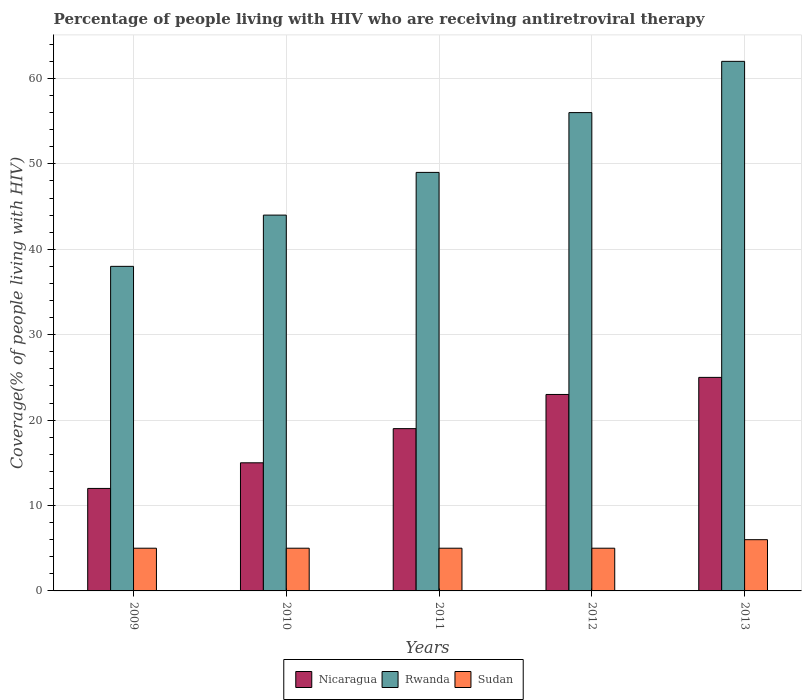How many groups of bars are there?
Your answer should be compact. 5. Are the number of bars on each tick of the X-axis equal?
Ensure brevity in your answer.  Yes. How many bars are there on the 1st tick from the left?
Offer a very short reply. 3. How many bars are there on the 1st tick from the right?
Your answer should be very brief. 3. What is the percentage of the HIV infected people who are receiving antiretroviral therapy in Nicaragua in 2011?
Your answer should be very brief. 19. Across all years, what is the maximum percentage of the HIV infected people who are receiving antiretroviral therapy in Nicaragua?
Give a very brief answer. 25. Across all years, what is the minimum percentage of the HIV infected people who are receiving antiretroviral therapy in Nicaragua?
Ensure brevity in your answer.  12. In which year was the percentage of the HIV infected people who are receiving antiretroviral therapy in Rwanda minimum?
Offer a very short reply. 2009. What is the total percentage of the HIV infected people who are receiving antiretroviral therapy in Rwanda in the graph?
Keep it short and to the point. 249. What is the difference between the percentage of the HIV infected people who are receiving antiretroviral therapy in Nicaragua in 2009 and that in 2012?
Offer a terse response. -11. What is the difference between the percentage of the HIV infected people who are receiving antiretroviral therapy in Rwanda in 2009 and the percentage of the HIV infected people who are receiving antiretroviral therapy in Sudan in 2013?
Make the answer very short. 32. What is the average percentage of the HIV infected people who are receiving antiretroviral therapy in Sudan per year?
Your response must be concise. 5.2. In the year 2010, what is the difference between the percentage of the HIV infected people who are receiving antiretroviral therapy in Sudan and percentage of the HIV infected people who are receiving antiretroviral therapy in Nicaragua?
Offer a terse response. -10. In how many years, is the percentage of the HIV infected people who are receiving antiretroviral therapy in Sudan greater than 30 %?
Make the answer very short. 0. What is the ratio of the percentage of the HIV infected people who are receiving antiretroviral therapy in Rwanda in 2011 to that in 2013?
Make the answer very short. 0.79. What is the difference between the highest and the second highest percentage of the HIV infected people who are receiving antiretroviral therapy in Nicaragua?
Give a very brief answer. 2. What is the difference between the highest and the lowest percentage of the HIV infected people who are receiving antiretroviral therapy in Nicaragua?
Your answer should be very brief. 13. What does the 1st bar from the left in 2011 represents?
Give a very brief answer. Nicaragua. What does the 1st bar from the right in 2009 represents?
Your answer should be very brief. Sudan. Is it the case that in every year, the sum of the percentage of the HIV infected people who are receiving antiretroviral therapy in Sudan and percentage of the HIV infected people who are receiving antiretroviral therapy in Rwanda is greater than the percentage of the HIV infected people who are receiving antiretroviral therapy in Nicaragua?
Your answer should be compact. Yes. How many bars are there?
Your response must be concise. 15. Are all the bars in the graph horizontal?
Offer a very short reply. No. How many years are there in the graph?
Keep it short and to the point. 5. What is the difference between two consecutive major ticks on the Y-axis?
Your response must be concise. 10. Does the graph contain grids?
Provide a short and direct response. Yes. How many legend labels are there?
Offer a terse response. 3. How are the legend labels stacked?
Your answer should be very brief. Horizontal. What is the title of the graph?
Offer a very short reply. Percentage of people living with HIV who are receiving antiretroviral therapy. What is the label or title of the Y-axis?
Provide a short and direct response. Coverage(% of people living with HIV). What is the Coverage(% of people living with HIV) of Nicaragua in 2009?
Make the answer very short. 12. What is the Coverage(% of people living with HIV) of Sudan in 2009?
Offer a terse response. 5. What is the Coverage(% of people living with HIV) in Nicaragua in 2010?
Keep it short and to the point. 15. What is the Coverage(% of people living with HIV) of Sudan in 2010?
Make the answer very short. 5. What is the Coverage(% of people living with HIV) in Nicaragua in 2011?
Your answer should be very brief. 19. What is the Coverage(% of people living with HIV) of Nicaragua in 2013?
Give a very brief answer. 25. What is the Coverage(% of people living with HIV) in Sudan in 2013?
Your answer should be compact. 6. Across all years, what is the maximum Coverage(% of people living with HIV) in Rwanda?
Provide a succinct answer. 62. Across all years, what is the maximum Coverage(% of people living with HIV) in Sudan?
Your answer should be very brief. 6. What is the total Coverage(% of people living with HIV) of Nicaragua in the graph?
Keep it short and to the point. 94. What is the total Coverage(% of people living with HIV) in Rwanda in the graph?
Ensure brevity in your answer.  249. What is the difference between the Coverage(% of people living with HIV) in Nicaragua in 2009 and that in 2011?
Give a very brief answer. -7. What is the difference between the Coverage(% of people living with HIV) of Rwanda in 2009 and that in 2011?
Make the answer very short. -11. What is the difference between the Coverage(% of people living with HIV) of Sudan in 2009 and that in 2011?
Keep it short and to the point. 0. What is the difference between the Coverage(% of people living with HIV) of Nicaragua in 2009 and that in 2012?
Give a very brief answer. -11. What is the difference between the Coverage(% of people living with HIV) of Rwanda in 2009 and that in 2013?
Offer a very short reply. -24. What is the difference between the Coverage(% of people living with HIV) in Sudan in 2009 and that in 2013?
Your answer should be compact. -1. What is the difference between the Coverage(% of people living with HIV) in Nicaragua in 2010 and that in 2011?
Ensure brevity in your answer.  -4. What is the difference between the Coverage(% of people living with HIV) of Nicaragua in 2010 and that in 2013?
Give a very brief answer. -10. What is the difference between the Coverage(% of people living with HIV) of Rwanda in 2010 and that in 2013?
Make the answer very short. -18. What is the difference between the Coverage(% of people living with HIV) of Nicaragua in 2011 and that in 2012?
Keep it short and to the point. -4. What is the difference between the Coverage(% of people living with HIV) of Sudan in 2011 and that in 2013?
Your answer should be compact. -1. What is the difference between the Coverage(% of people living with HIV) in Rwanda in 2012 and that in 2013?
Provide a succinct answer. -6. What is the difference between the Coverage(% of people living with HIV) in Nicaragua in 2009 and the Coverage(% of people living with HIV) in Rwanda in 2010?
Provide a short and direct response. -32. What is the difference between the Coverage(% of people living with HIV) of Nicaragua in 2009 and the Coverage(% of people living with HIV) of Rwanda in 2011?
Offer a terse response. -37. What is the difference between the Coverage(% of people living with HIV) of Nicaragua in 2009 and the Coverage(% of people living with HIV) of Sudan in 2011?
Make the answer very short. 7. What is the difference between the Coverage(% of people living with HIV) in Nicaragua in 2009 and the Coverage(% of people living with HIV) in Rwanda in 2012?
Your answer should be compact. -44. What is the difference between the Coverage(% of people living with HIV) in Rwanda in 2009 and the Coverage(% of people living with HIV) in Sudan in 2012?
Make the answer very short. 33. What is the difference between the Coverage(% of people living with HIV) of Nicaragua in 2009 and the Coverage(% of people living with HIV) of Rwanda in 2013?
Keep it short and to the point. -50. What is the difference between the Coverage(% of people living with HIV) in Nicaragua in 2009 and the Coverage(% of people living with HIV) in Sudan in 2013?
Ensure brevity in your answer.  6. What is the difference between the Coverage(% of people living with HIV) of Nicaragua in 2010 and the Coverage(% of people living with HIV) of Rwanda in 2011?
Ensure brevity in your answer.  -34. What is the difference between the Coverage(% of people living with HIV) in Rwanda in 2010 and the Coverage(% of people living with HIV) in Sudan in 2011?
Offer a very short reply. 39. What is the difference between the Coverage(% of people living with HIV) of Nicaragua in 2010 and the Coverage(% of people living with HIV) of Rwanda in 2012?
Offer a very short reply. -41. What is the difference between the Coverage(% of people living with HIV) in Nicaragua in 2010 and the Coverage(% of people living with HIV) in Sudan in 2012?
Your answer should be very brief. 10. What is the difference between the Coverage(% of people living with HIV) of Rwanda in 2010 and the Coverage(% of people living with HIV) of Sudan in 2012?
Provide a succinct answer. 39. What is the difference between the Coverage(% of people living with HIV) in Nicaragua in 2010 and the Coverage(% of people living with HIV) in Rwanda in 2013?
Keep it short and to the point. -47. What is the difference between the Coverage(% of people living with HIV) of Rwanda in 2010 and the Coverage(% of people living with HIV) of Sudan in 2013?
Offer a terse response. 38. What is the difference between the Coverage(% of people living with HIV) of Nicaragua in 2011 and the Coverage(% of people living with HIV) of Rwanda in 2012?
Provide a succinct answer. -37. What is the difference between the Coverage(% of people living with HIV) of Nicaragua in 2011 and the Coverage(% of people living with HIV) of Sudan in 2012?
Your answer should be compact. 14. What is the difference between the Coverage(% of people living with HIV) of Nicaragua in 2011 and the Coverage(% of people living with HIV) of Rwanda in 2013?
Your answer should be very brief. -43. What is the difference between the Coverage(% of people living with HIV) of Nicaragua in 2012 and the Coverage(% of people living with HIV) of Rwanda in 2013?
Give a very brief answer. -39. What is the difference between the Coverage(% of people living with HIV) in Rwanda in 2012 and the Coverage(% of people living with HIV) in Sudan in 2013?
Give a very brief answer. 50. What is the average Coverage(% of people living with HIV) of Rwanda per year?
Keep it short and to the point. 49.8. In the year 2009, what is the difference between the Coverage(% of people living with HIV) in Nicaragua and Coverage(% of people living with HIV) in Sudan?
Provide a short and direct response. 7. In the year 2010, what is the difference between the Coverage(% of people living with HIV) in Nicaragua and Coverage(% of people living with HIV) in Rwanda?
Offer a very short reply. -29. In the year 2012, what is the difference between the Coverage(% of people living with HIV) in Nicaragua and Coverage(% of people living with HIV) in Rwanda?
Your answer should be compact. -33. In the year 2013, what is the difference between the Coverage(% of people living with HIV) of Nicaragua and Coverage(% of people living with HIV) of Rwanda?
Provide a succinct answer. -37. In the year 2013, what is the difference between the Coverage(% of people living with HIV) of Rwanda and Coverage(% of people living with HIV) of Sudan?
Provide a succinct answer. 56. What is the ratio of the Coverage(% of people living with HIV) in Rwanda in 2009 to that in 2010?
Your answer should be compact. 0.86. What is the ratio of the Coverage(% of people living with HIV) in Nicaragua in 2009 to that in 2011?
Make the answer very short. 0.63. What is the ratio of the Coverage(% of people living with HIV) of Rwanda in 2009 to that in 2011?
Keep it short and to the point. 0.78. What is the ratio of the Coverage(% of people living with HIV) in Sudan in 2009 to that in 2011?
Make the answer very short. 1. What is the ratio of the Coverage(% of people living with HIV) of Nicaragua in 2009 to that in 2012?
Keep it short and to the point. 0.52. What is the ratio of the Coverage(% of people living with HIV) in Rwanda in 2009 to that in 2012?
Your response must be concise. 0.68. What is the ratio of the Coverage(% of people living with HIV) of Sudan in 2009 to that in 2012?
Your answer should be compact. 1. What is the ratio of the Coverage(% of people living with HIV) of Nicaragua in 2009 to that in 2013?
Provide a succinct answer. 0.48. What is the ratio of the Coverage(% of people living with HIV) of Rwanda in 2009 to that in 2013?
Ensure brevity in your answer.  0.61. What is the ratio of the Coverage(% of people living with HIV) of Sudan in 2009 to that in 2013?
Provide a short and direct response. 0.83. What is the ratio of the Coverage(% of people living with HIV) of Nicaragua in 2010 to that in 2011?
Your answer should be very brief. 0.79. What is the ratio of the Coverage(% of people living with HIV) in Rwanda in 2010 to that in 2011?
Your response must be concise. 0.9. What is the ratio of the Coverage(% of people living with HIV) in Sudan in 2010 to that in 2011?
Your answer should be compact. 1. What is the ratio of the Coverage(% of people living with HIV) of Nicaragua in 2010 to that in 2012?
Your answer should be compact. 0.65. What is the ratio of the Coverage(% of people living with HIV) of Rwanda in 2010 to that in 2012?
Ensure brevity in your answer.  0.79. What is the ratio of the Coverage(% of people living with HIV) in Nicaragua in 2010 to that in 2013?
Make the answer very short. 0.6. What is the ratio of the Coverage(% of people living with HIV) in Rwanda in 2010 to that in 2013?
Give a very brief answer. 0.71. What is the ratio of the Coverage(% of people living with HIV) of Sudan in 2010 to that in 2013?
Make the answer very short. 0.83. What is the ratio of the Coverage(% of people living with HIV) in Nicaragua in 2011 to that in 2012?
Make the answer very short. 0.83. What is the ratio of the Coverage(% of people living with HIV) in Nicaragua in 2011 to that in 2013?
Keep it short and to the point. 0.76. What is the ratio of the Coverage(% of people living with HIV) in Rwanda in 2011 to that in 2013?
Provide a succinct answer. 0.79. What is the ratio of the Coverage(% of people living with HIV) in Sudan in 2011 to that in 2013?
Keep it short and to the point. 0.83. What is the ratio of the Coverage(% of people living with HIV) in Nicaragua in 2012 to that in 2013?
Offer a terse response. 0.92. What is the ratio of the Coverage(% of people living with HIV) of Rwanda in 2012 to that in 2013?
Your answer should be compact. 0.9. What is the difference between the highest and the second highest Coverage(% of people living with HIV) of Nicaragua?
Your answer should be compact. 2. What is the difference between the highest and the second highest Coverage(% of people living with HIV) in Sudan?
Keep it short and to the point. 1. What is the difference between the highest and the lowest Coverage(% of people living with HIV) of Sudan?
Provide a short and direct response. 1. 